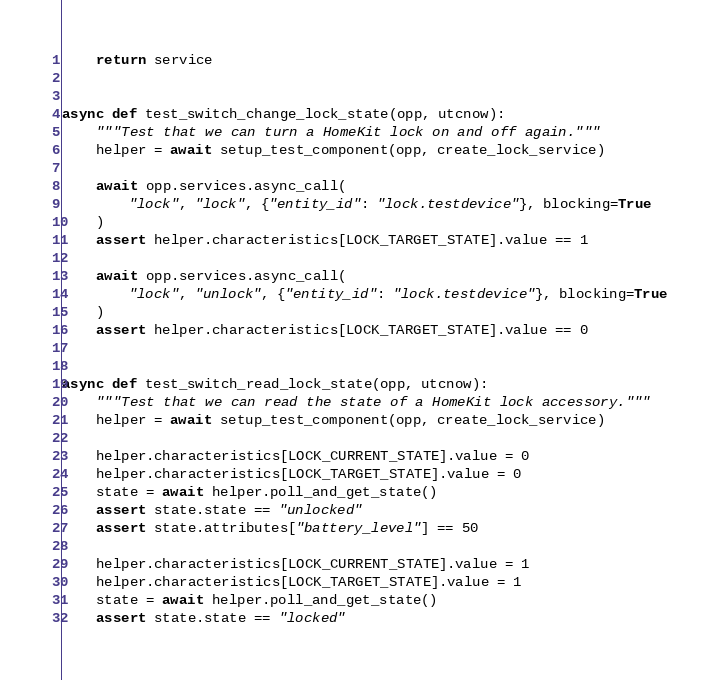Convert code to text. <code><loc_0><loc_0><loc_500><loc_500><_Python_>
    return service


async def test_switch_change_lock_state(opp, utcnow):
    """Test that we can turn a HomeKit lock on and off again."""
    helper = await setup_test_component(opp, create_lock_service)

    await opp.services.async_call(
        "lock", "lock", {"entity_id": "lock.testdevice"}, blocking=True
    )
    assert helper.characteristics[LOCK_TARGET_STATE].value == 1

    await opp.services.async_call(
        "lock", "unlock", {"entity_id": "lock.testdevice"}, blocking=True
    )
    assert helper.characteristics[LOCK_TARGET_STATE].value == 0


async def test_switch_read_lock_state(opp, utcnow):
    """Test that we can read the state of a HomeKit lock accessory."""
    helper = await setup_test_component(opp, create_lock_service)

    helper.characteristics[LOCK_CURRENT_STATE].value = 0
    helper.characteristics[LOCK_TARGET_STATE].value = 0
    state = await helper.poll_and_get_state()
    assert state.state == "unlocked"
    assert state.attributes["battery_level"] == 50

    helper.characteristics[LOCK_CURRENT_STATE].value = 1
    helper.characteristics[LOCK_TARGET_STATE].value = 1
    state = await helper.poll_and_get_state()
    assert state.state == "locked"
</code> 